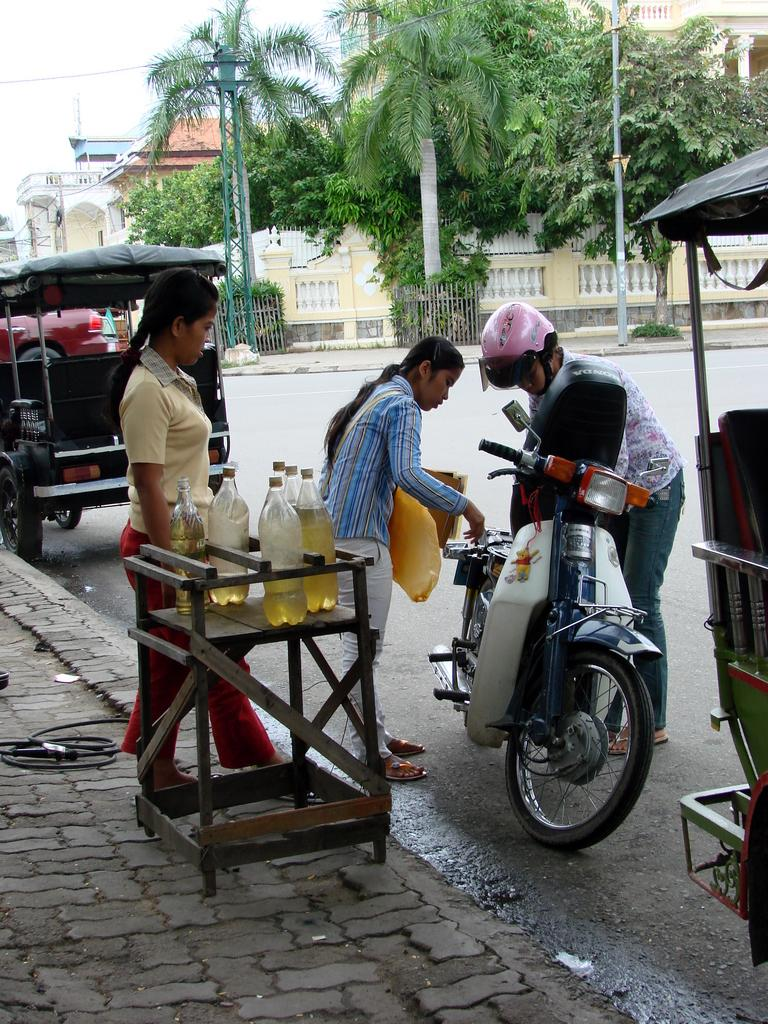How many people are standing in the image? There are three people standing on the ground in the image. What objects can be seen besides the people? Bottles, a table, a scooter, vehicles, poles, trees, buildings, and the sky are visible in the image. What type of surface are the people standing on? The people are standing on the ground. What is the background of the image? The sky is visible in the background of the image. Can you see any waves in the image? There are no waves present in the image. Is there a wing visible in the image? There is no wing present in the image. 